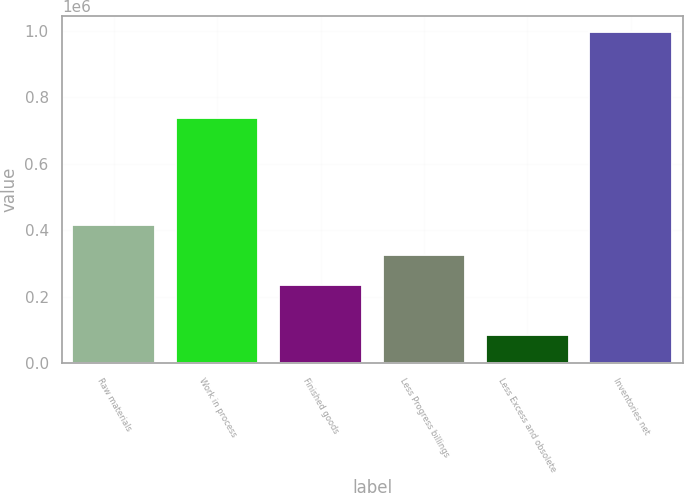Convert chart to OTSL. <chart><loc_0><loc_0><loc_500><loc_500><bar_chart><fcel>Raw materials<fcel>Work in process<fcel>Finished goods<fcel>Less Progress billings<fcel>Less Excess and obsolete<fcel>Inventories net<nl><fcel>417364<fcel>739227<fcel>235083<fcel>326223<fcel>84161<fcel>995565<nl></chart> 